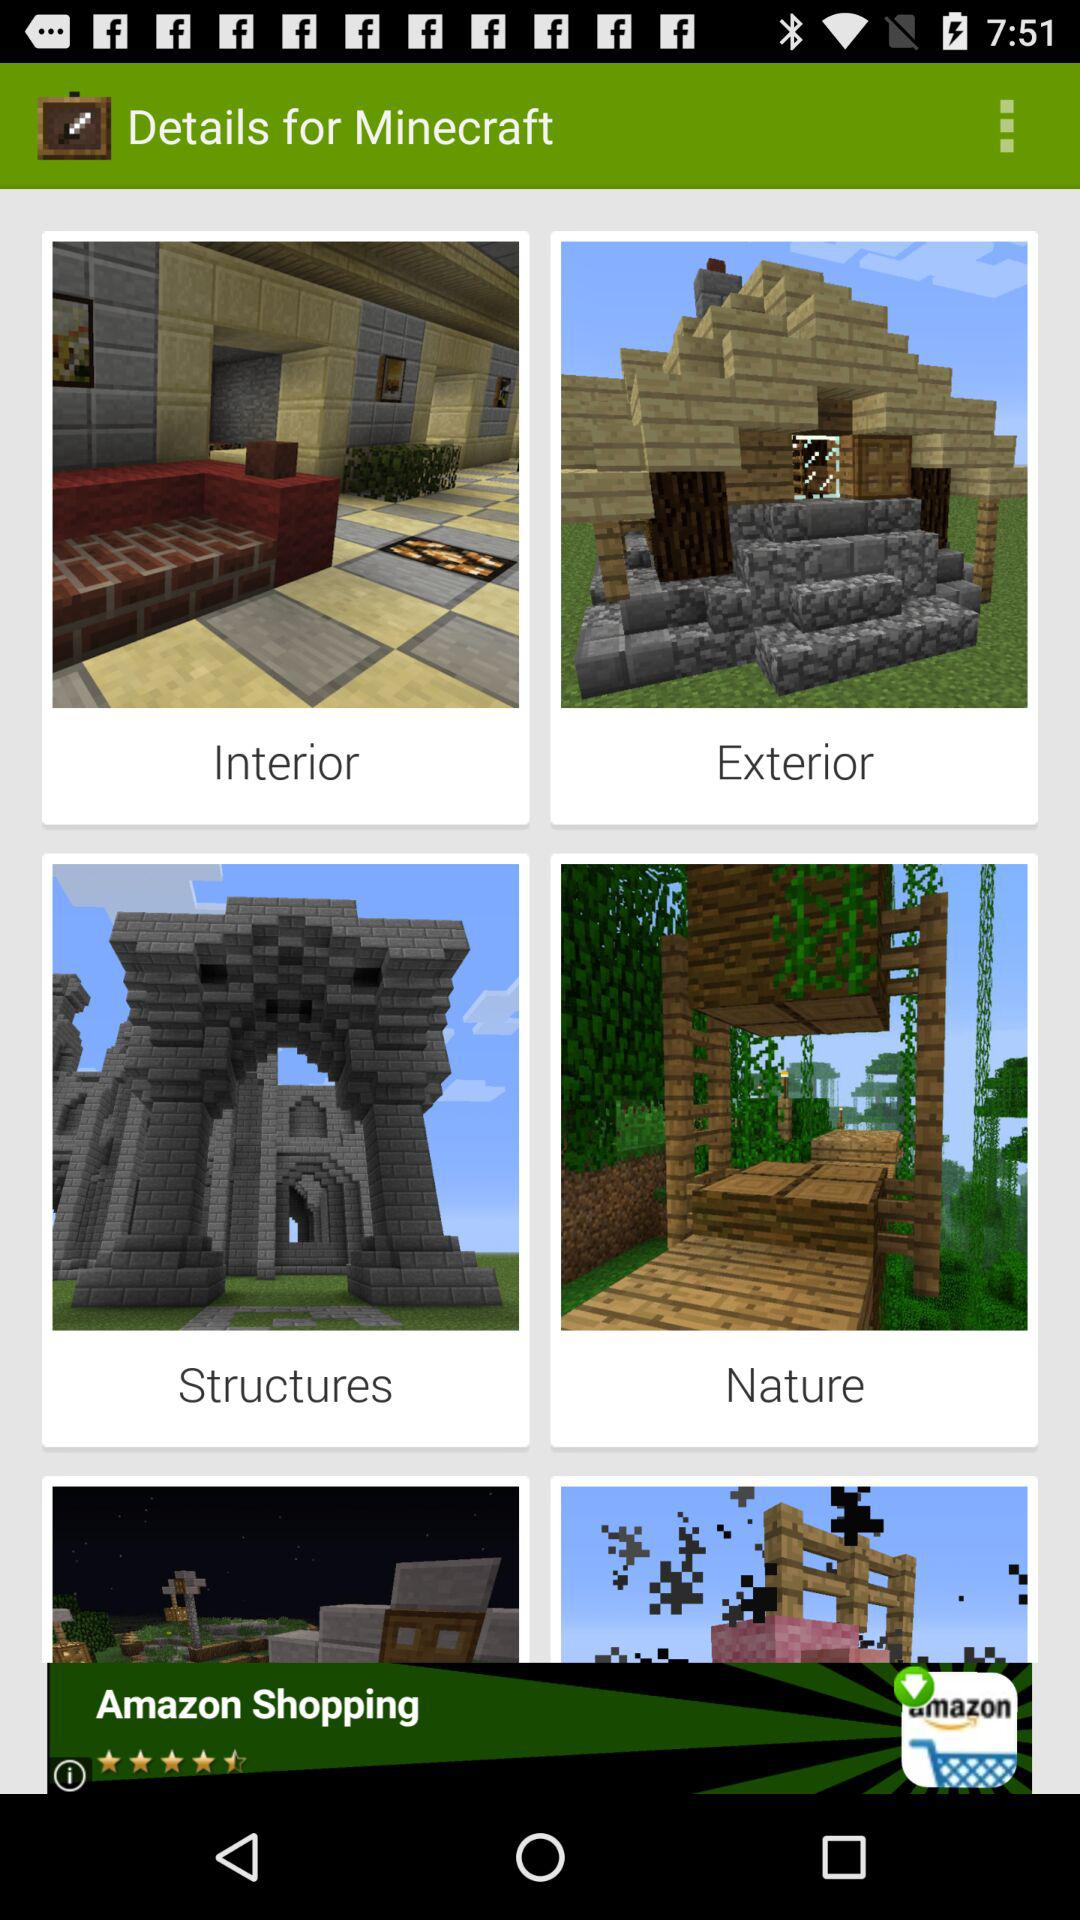When was "Interior" posted?
When the provided information is insufficient, respond with <no answer>. <no answer> 